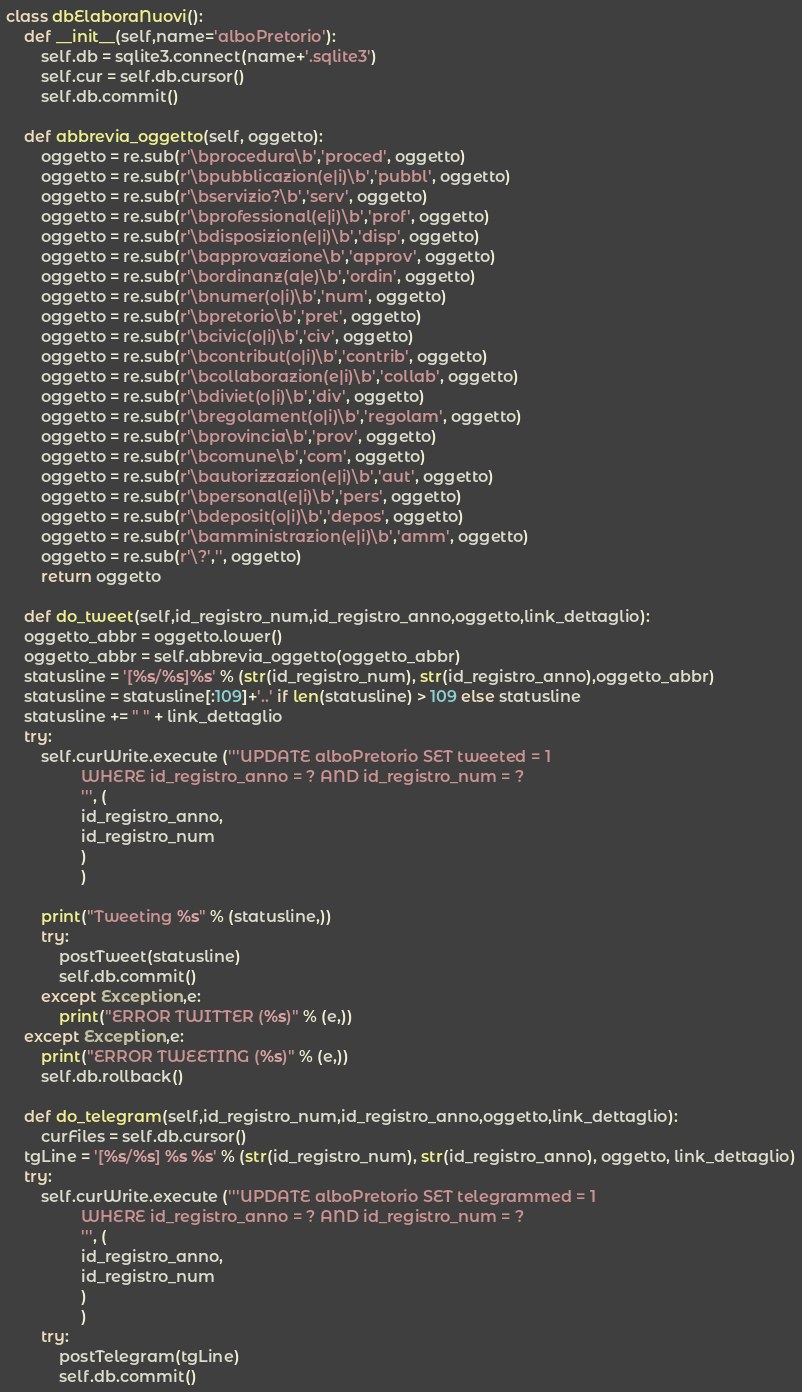Convert code to text. <code><loc_0><loc_0><loc_500><loc_500><_Python_>
class dbElaboraNuovi():
    def __init__(self,name='alboPretorio'):
        self.db = sqlite3.connect(name+'.sqlite3')
        self.cur = self.db.cursor()
        self.db.commit()

    def abbrevia_oggetto(self, oggetto):
        oggetto = re.sub(r'\bprocedura\b','proced', oggetto)
        oggetto = re.sub(r'\bpubblicazion(e|i)\b','pubbl', oggetto)
        oggetto = re.sub(r'\bservizio?\b','serv', oggetto)
        oggetto = re.sub(r'\bprofessional(e|i)\b','prof', oggetto)
        oggetto = re.sub(r'\bdisposizion(e|i)\b','disp', oggetto)
        oggetto = re.sub(r'\bapprovazione\b','approv', oggetto)
        oggetto = re.sub(r'\bordinanz(a|e)\b','ordin', oggetto)
        oggetto = re.sub(r'\bnumer(o|i)\b','num', oggetto)
        oggetto = re.sub(r'\bpretorio\b','pret', oggetto)
        oggetto = re.sub(r'\bcivic(o|i)\b','civ', oggetto)
        oggetto = re.sub(r'\bcontribut(o|i)\b','contrib', oggetto)
        oggetto = re.sub(r'\bcollaborazion(e|i)\b','collab', oggetto)
        oggetto = re.sub(r'\bdiviet(o|i)\b','div', oggetto)
        oggetto = re.sub(r'\bregolament(o|i)\b','regolam', oggetto)
        oggetto = re.sub(r'\bprovincia\b','prov', oggetto)
        oggetto = re.sub(r'\bcomune\b','com', oggetto)
        oggetto = re.sub(r'\bautorizzazion(e|i)\b','aut', oggetto)
        oggetto = re.sub(r'\bpersonal(e|i)\b','pers', oggetto)
        oggetto = re.sub(r'\bdeposit(o|i)\b','depos', oggetto)
        oggetto = re.sub(r'\bamministrazion(e|i)\b','amm', oggetto)
        oggetto = re.sub(r'\?','', oggetto)
        return oggetto

    def do_tweet(self,id_registro_num,id_registro_anno,oggetto,link_dettaglio):
	oggetto_abbr = oggetto.lower()
	oggetto_abbr = self.abbrevia_oggetto(oggetto_abbr)
	statusline = '[%s/%s]%s' % (str(id_registro_num), str(id_registro_anno),oggetto_abbr)
	statusline = statusline[:109]+'..' if len(statusline) > 109 else statusline
	statusline += " " + link_dettaglio
	try:
	    self.curWrite.execute ('''UPDATE alboPretorio SET tweeted = 1
				 WHERE id_registro_anno = ? AND id_registro_num = ?
			     ''', (
				 id_registro_anno,
				 id_registro_num
				 )
			     )

	    print("Tweeting %s" % (statusline,))
	    try:
		    postTweet(statusline)
		    self.db.commit()
	    except Exception,e: 
		    print("ERROR TWITTER (%s)" % (e,))
	except Exception,e: 
	    print("ERROR TWEETING (%s)" % (e,))
	    self.db.rollback()

    def do_telegram(self,id_registro_num,id_registro_anno,oggetto,link_dettaglio):
        curFiles = self.db.cursor()
	tgLine = '[%s/%s] %s %s' % (str(id_registro_num), str(id_registro_anno), oggetto, link_dettaglio)
	try:
	    self.curWrite.execute ('''UPDATE alboPretorio SET telegrammed = 1
				 WHERE id_registro_anno = ? AND id_registro_num = ?
			     ''', (
				 id_registro_anno,
				 id_registro_num
				 )
			     )
	    try:
		    postTelegram(tgLine)
		    self.db.commit()</code> 